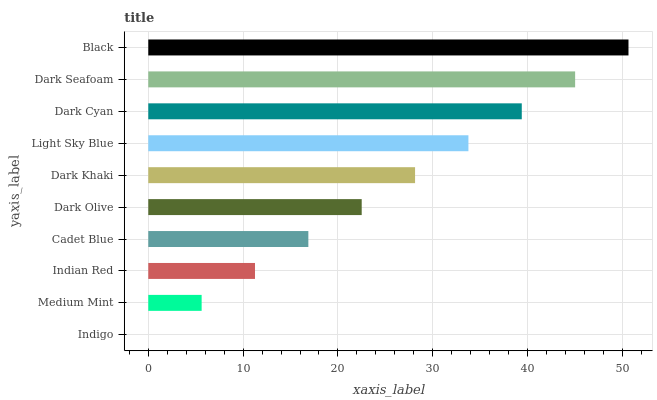Is Indigo the minimum?
Answer yes or no. Yes. Is Black the maximum?
Answer yes or no. Yes. Is Medium Mint the minimum?
Answer yes or no. No. Is Medium Mint the maximum?
Answer yes or no. No. Is Medium Mint greater than Indigo?
Answer yes or no. Yes. Is Indigo less than Medium Mint?
Answer yes or no. Yes. Is Indigo greater than Medium Mint?
Answer yes or no. No. Is Medium Mint less than Indigo?
Answer yes or no. No. Is Dark Khaki the high median?
Answer yes or no. Yes. Is Dark Olive the low median?
Answer yes or no. Yes. Is Light Sky Blue the high median?
Answer yes or no. No. Is Indian Red the low median?
Answer yes or no. No. 